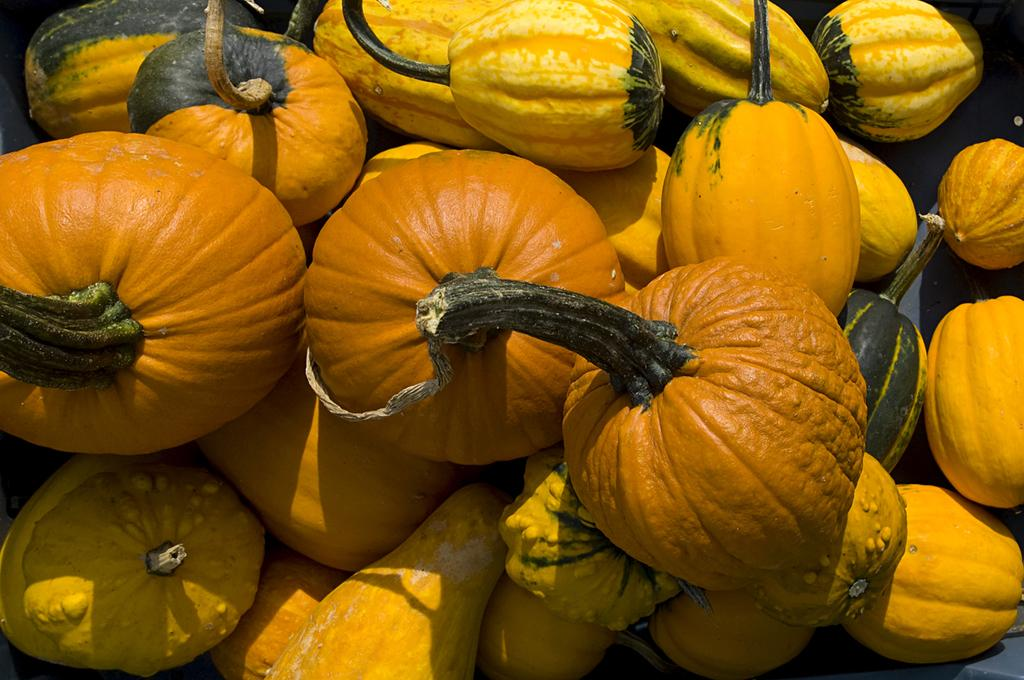What is the main subject of the image? The main subject of the image is a group of pumpkins. Where are the pumpkins located in the image? The pumpkins are placed on a platform. What type of title is written on the pumpkins in the image? There is no title written on the pumpkins in the image. What is being served for dinner in the image? There is no dinner being served in the image; it only features a group of pumpkins on a platform. 